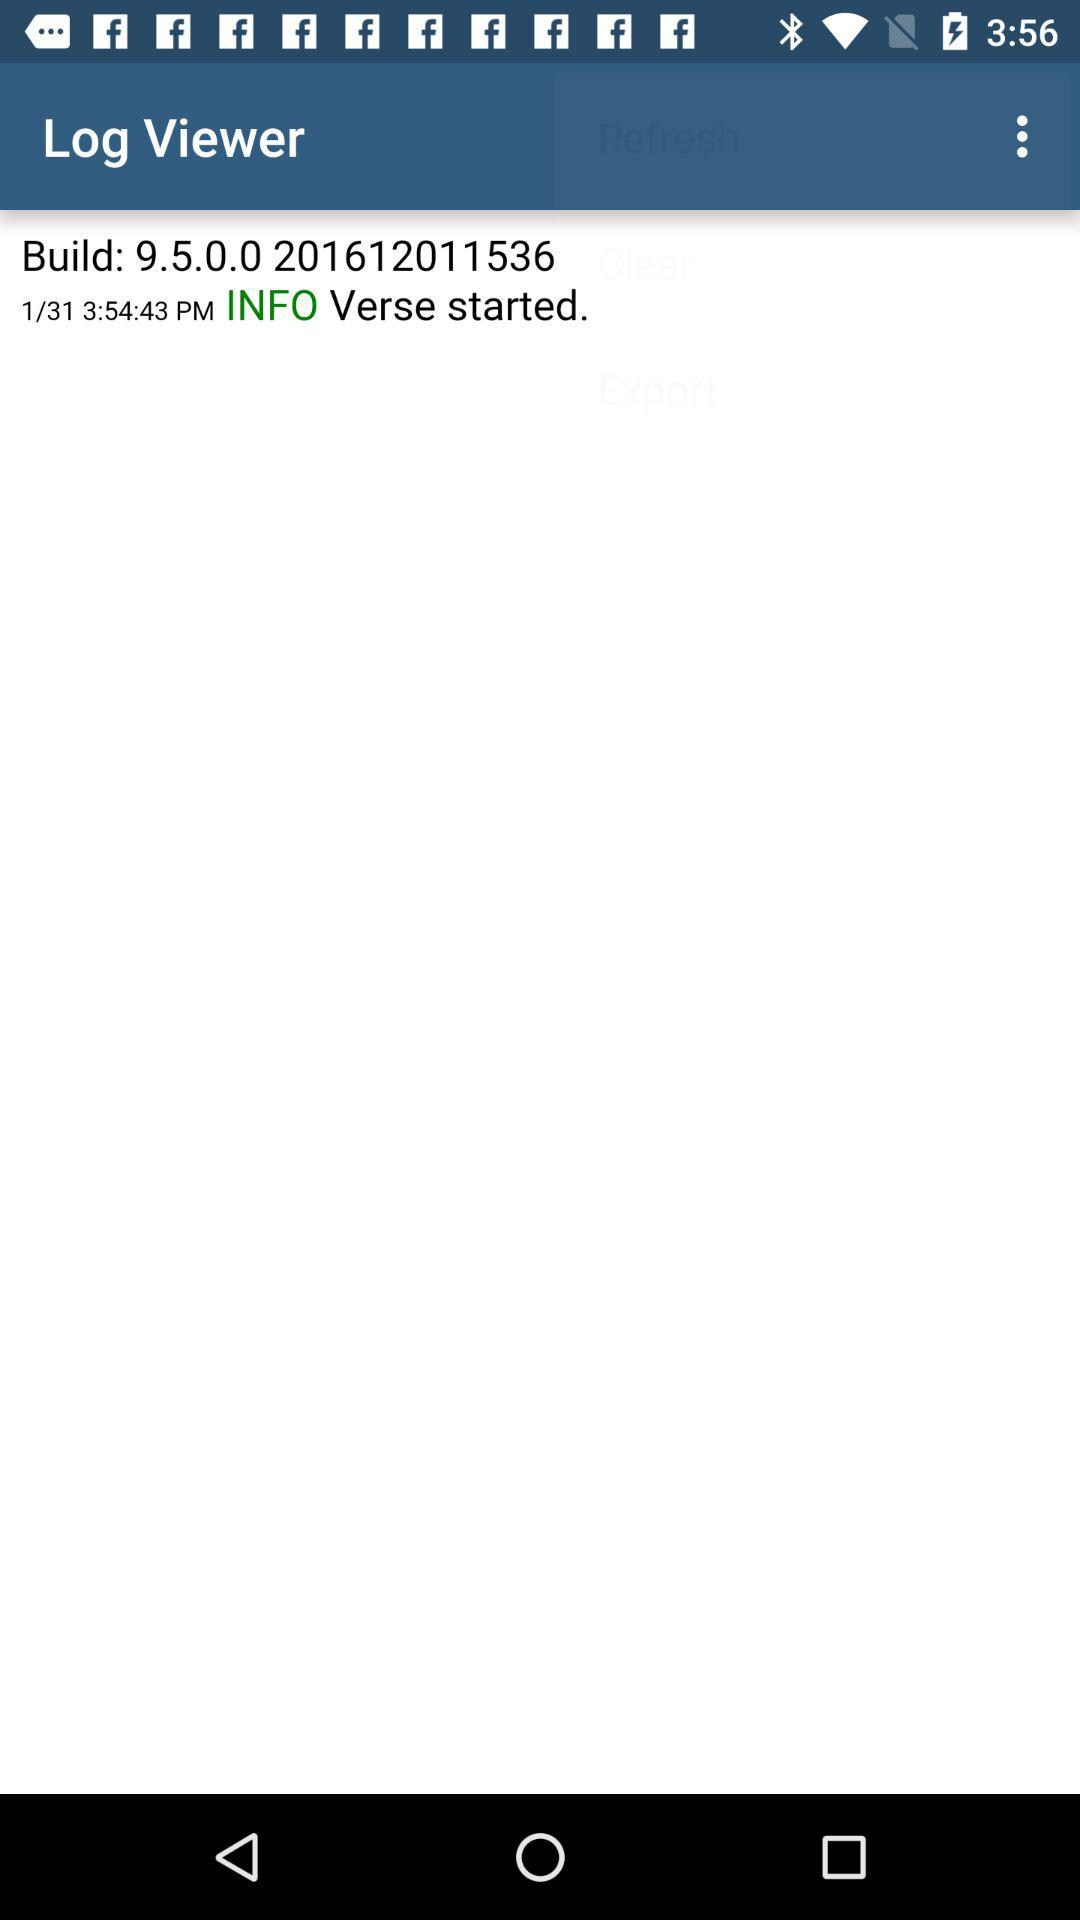Who is this application powered by?
When the provided information is insufficient, respond with <no answer>. <no answer> 